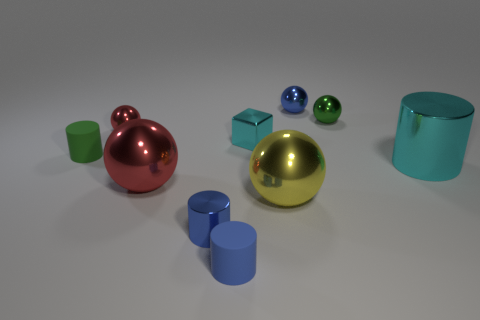Can you describe the colors and materials of the objects presented in this image? Certainly! There are two metallic spheres, one in copper-red and the other gold, a matte cube in light blue, three matte cylinders in blue, green, and teal, and two glossy spheres, one blue and one green. 